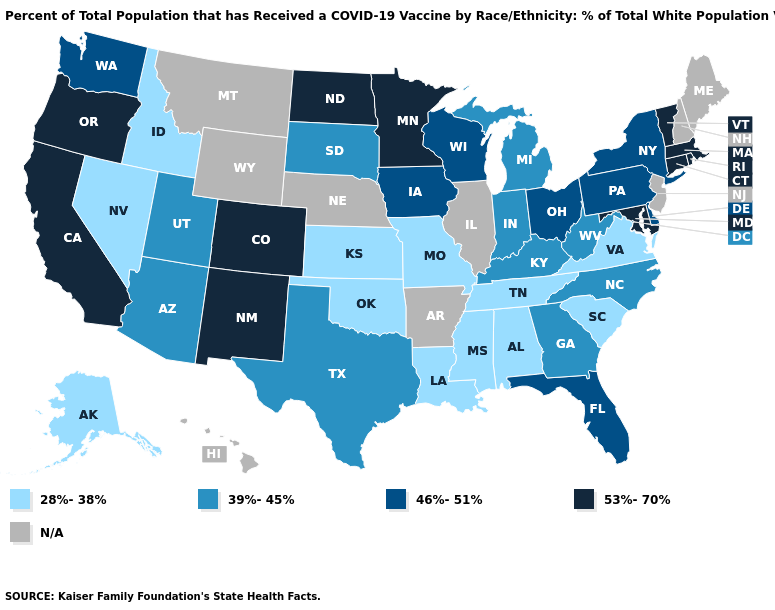Name the states that have a value in the range N/A?
Write a very short answer. Arkansas, Hawaii, Illinois, Maine, Montana, Nebraska, New Hampshire, New Jersey, Wyoming. Name the states that have a value in the range 39%-45%?
Concise answer only. Arizona, Georgia, Indiana, Kentucky, Michigan, North Carolina, South Dakota, Texas, Utah, West Virginia. Name the states that have a value in the range 46%-51%?
Keep it brief. Delaware, Florida, Iowa, New York, Ohio, Pennsylvania, Washington, Wisconsin. What is the value of Wyoming?
Keep it brief. N/A. What is the value of Hawaii?
Write a very short answer. N/A. Which states have the lowest value in the USA?
Short answer required. Alabama, Alaska, Idaho, Kansas, Louisiana, Mississippi, Missouri, Nevada, Oklahoma, South Carolina, Tennessee, Virginia. Name the states that have a value in the range N/A?
Concise answer only. Arkansas, Hawaii, Illinois, Maine, Montana, Nebraska, New Hampshire, New Jersey, Wyoming. What is the value of Pennsylvania?
Write a very short answer. 46%-51%. Does Tennessee have the lowest value in the South?
Answer briefly. Yes. What is the value of Kentucky?
Be succinct. 39%-45%. What is the value of Arizona?
Answer briefly. 39%-45%. Name the states that have a value in the range N/A?
Quick response, please. Arkansas, Hawaii, Illinois, Maine, Montana, Nebraska, New Hampshire, New Jersey, Wyoming. Name the states that have a value in the range N/A?
Give a very brief answer. Arkansas, Hawaii, Illinois, Maine, Montana, Nebraska, New Hampshire, New Jersey, Wyoming. What is the value of Maine?
Keep it brief. N/A. Does Kansas have the lowest value in the MidWest?
Concise answer only. Yes. 